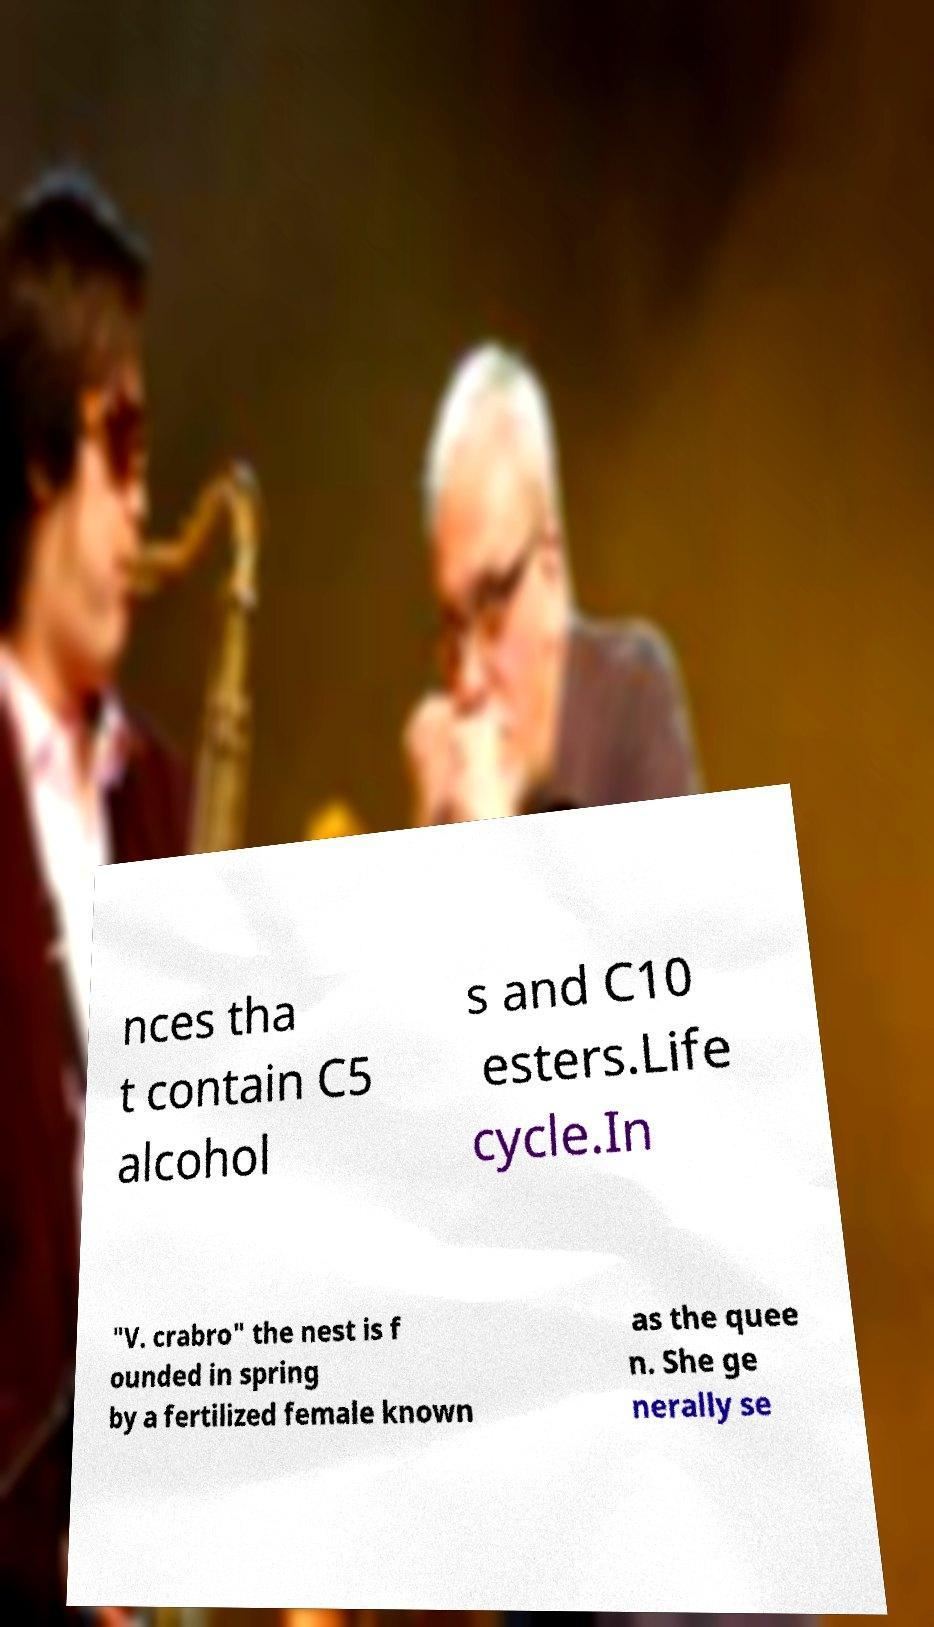Can you accurately transcribe the text from the provided image for me? nces tha t contain C5 alcohol s and C10 esters.Life cycle.In "V. crabro" the nest is f ounded in spring by a fertilized female known as the quee n. She ge nerally se 